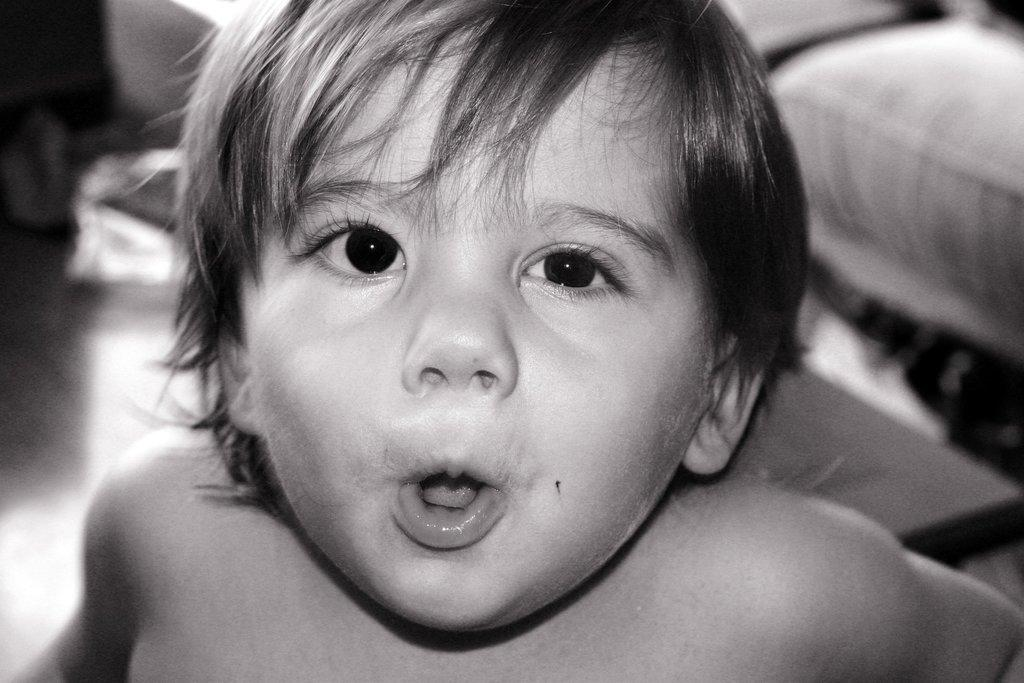What is the main subject in the front of the image? There is a child in the front of the image. What piece of furniture can be seen on the right side of the image? There is a sofa on the right side of the image. How would you describe the background of the image? The background of the image is blurred. How many frogs are sitting on the sofa in the image? There are no frogs present in the image; it features a child and a sofa. 